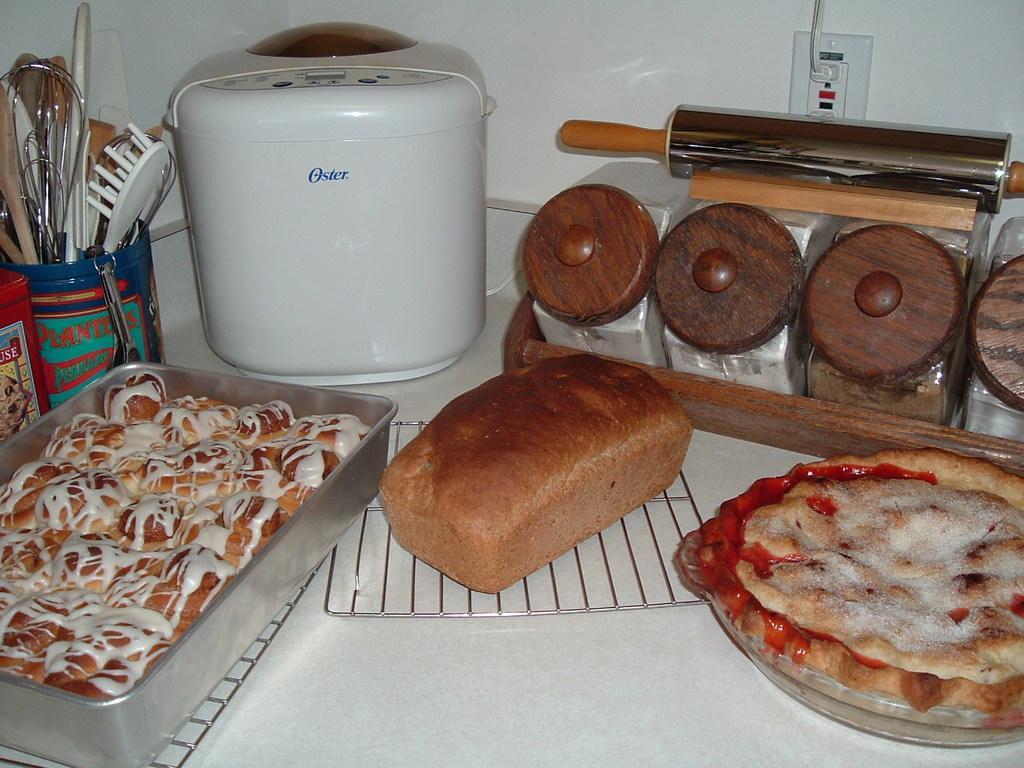Describe this image in one or two sentences. In this image I can see a table , on the table I can see a tray and on the tray I can see a food item and I can see bread pieces kept on the table , and I can see a wooden tray visible and I can see some objects and I can see a bowl and on the bowl I can see spoons and at the top I can see the wall and a cable card attached to the wall. 